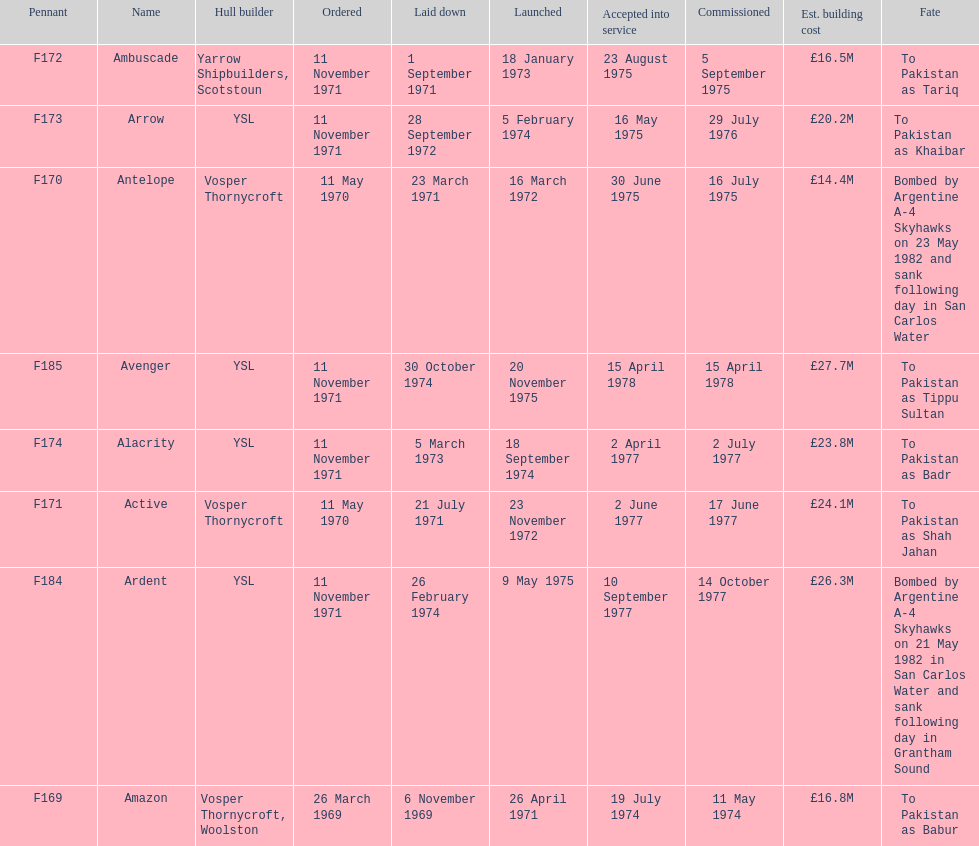Which ship had the highest estimated cost to build? Avenger. 